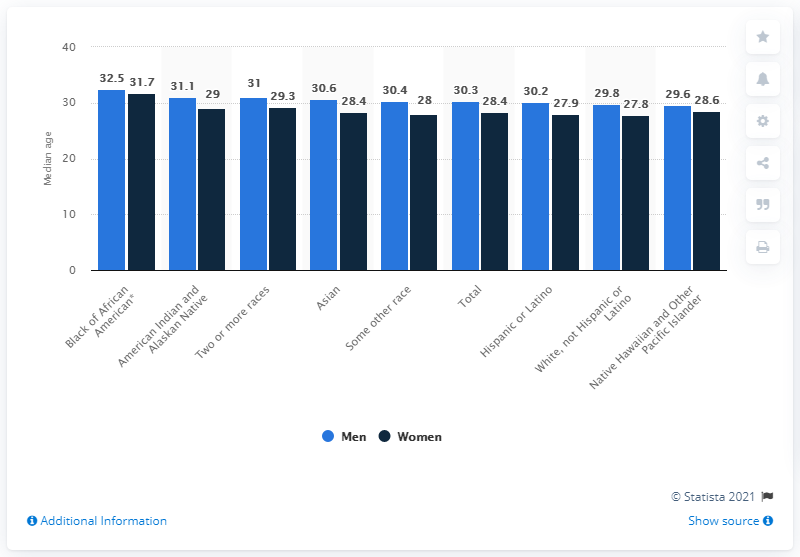Indicate a few pertinent items in this graphic. The median age for Asian men is 30.6 years old. The median age difference between Asian men and Black men is 1.9 years, according to the data. 